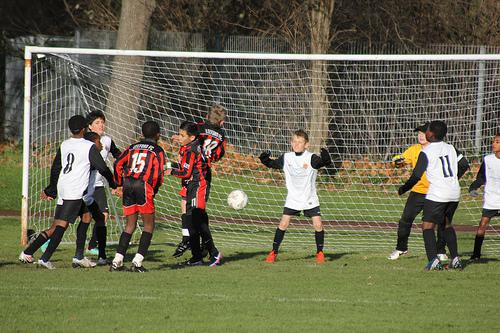Question: who is wearing orange cleats?
Choices:
A. Boy on the left.
B. Boy on the right.
C. Boy in back.
D. Boy in middle.
Answer with the letter. Answer: D Question: what sport is being played?
Choices:
A. Soccer.
B. Baseball.
C. Tennis.
D. Basketball.
Answer with the letter. Answer: A Question: how many boys are shown?
Choices:
A. 1.
B. 10.
C. 3.
D. 4.
Answer with the letter. Answer: B Question: why do the boys have different colored shirts?
Choices:
A. Different schools.
B. Different families.
C. Different teams.
D. Different towns.
Answer with the letter. Answer: C Question: what number is on the boy on the far right?
Choices:
A. 09.
B. 00.
C. 11.
D. 12.
Answer with the letter. Answer: C Question: how many colors does number 15's shirt have?
Choices:
A. 3.
B. 1.
C. 4.
D. 2.
Answer with the letter. Answer: A Question: who is wearing number 8?
Choices:
A. Boy on far left.
B. Boy on far right.
C. Girl on far left.
D. Girl on far right.
Answer with the letter. Answer: A 